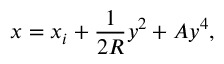Convert formula to latex. <formula><loc_0><loc_0><loc_500><loc_500>x = x _ { i } + \frac { 1 } { 2 R } y ^ { 2 } + A y ^ { 4 } ,</formula> 